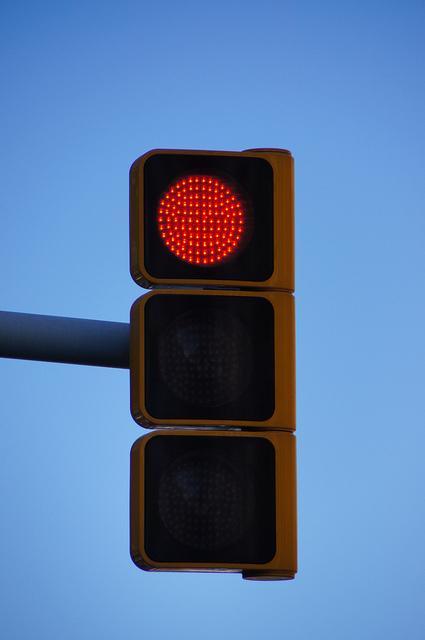What light is the stoplight on?
Keep it brief. Red. Are there clouds in the sky?
Give a very brief answer. No. What color is the light?
Keep it brief. Red. Are there clouds visible?
Quick response, please. No. Stop or go?
Write a very short answer. Stop. 